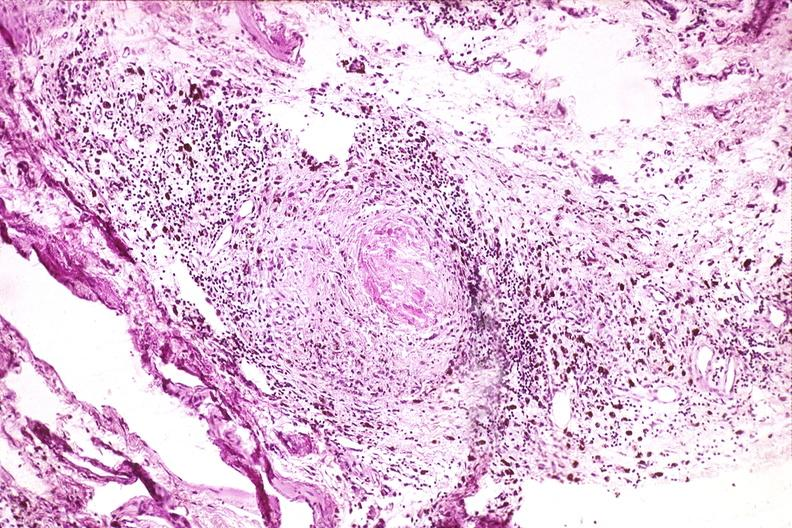does anomalous origin show synovium, pannus and fibrinoid necrosis, rheumatoid arthritis?
Answer the question using a single word or phrase. No 